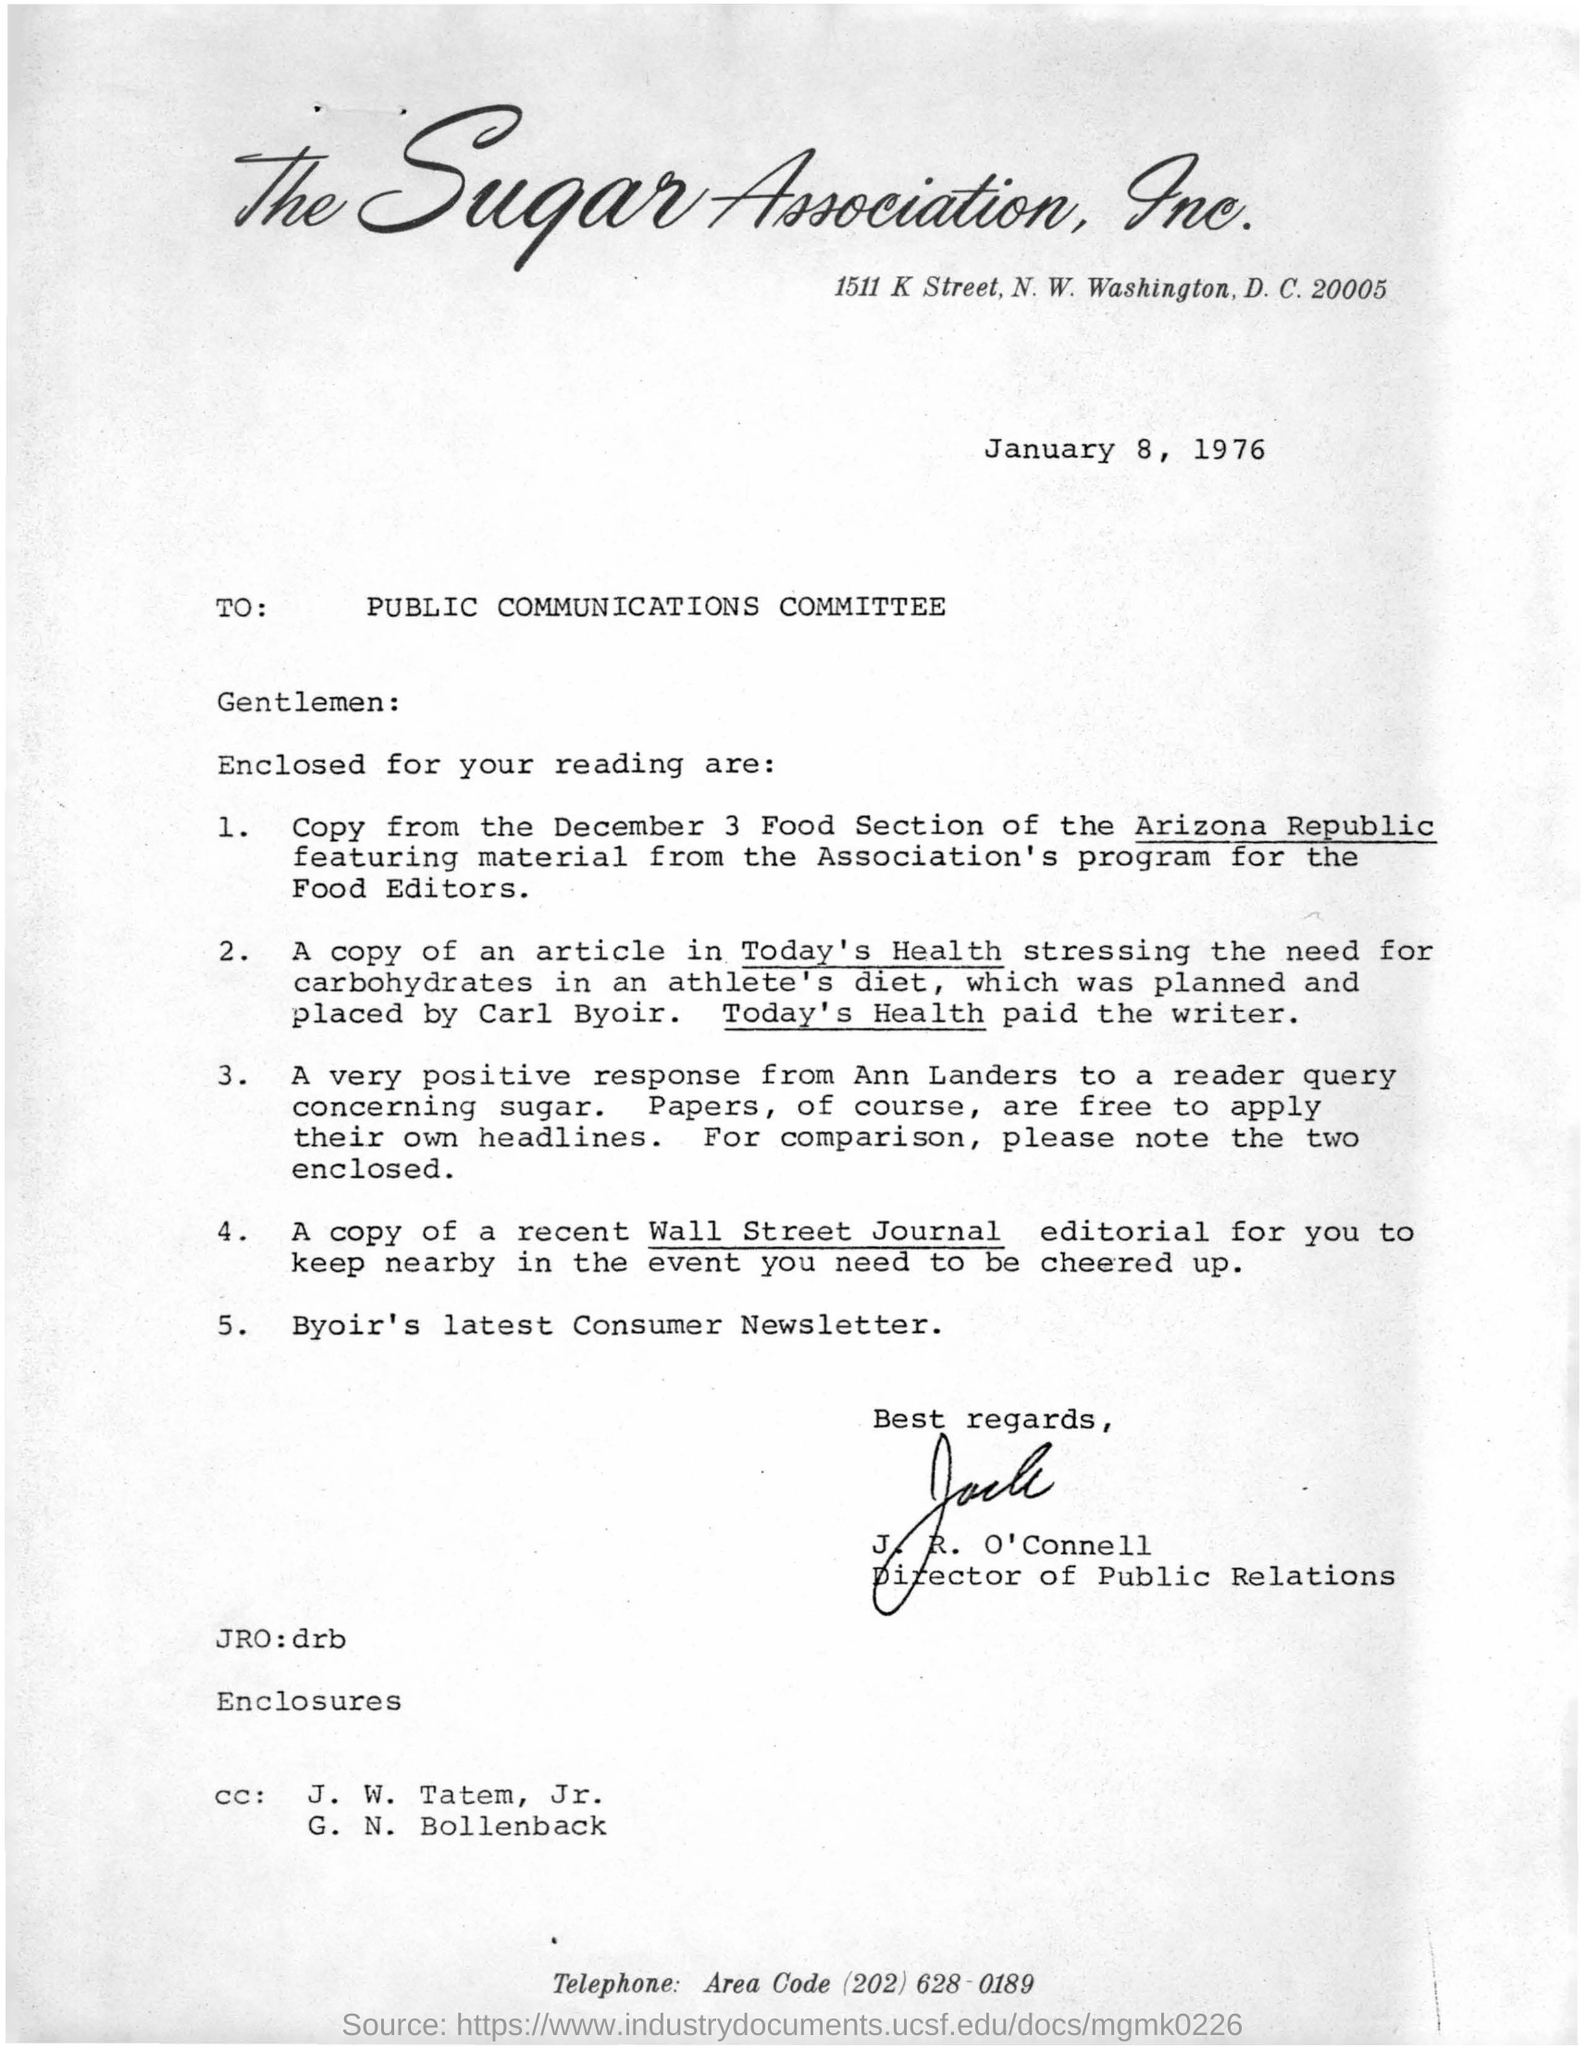Who  signed on the letter ?
Your answer should be very brief. J .R .O'Connell. Who had paid to the writer ?
Make the answer very short. Today's health. What is the name of the association ?
Make the answer very short. The sugar association, inc. Whats the 5th enclosure?
Give a very brief answer. Byoir's latest consumer newsletter. 